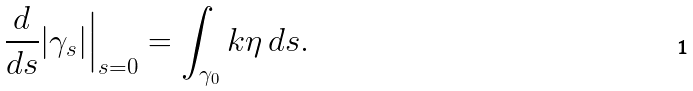<formula> <loc_0><loc_0><loc_500><loc_500>\frac { d } { d s } | \gamma _ { s } | \Big | _ { s = 0 } = \int _ { \gamma _ { 0 } } k \eta \, d s .</formula> 